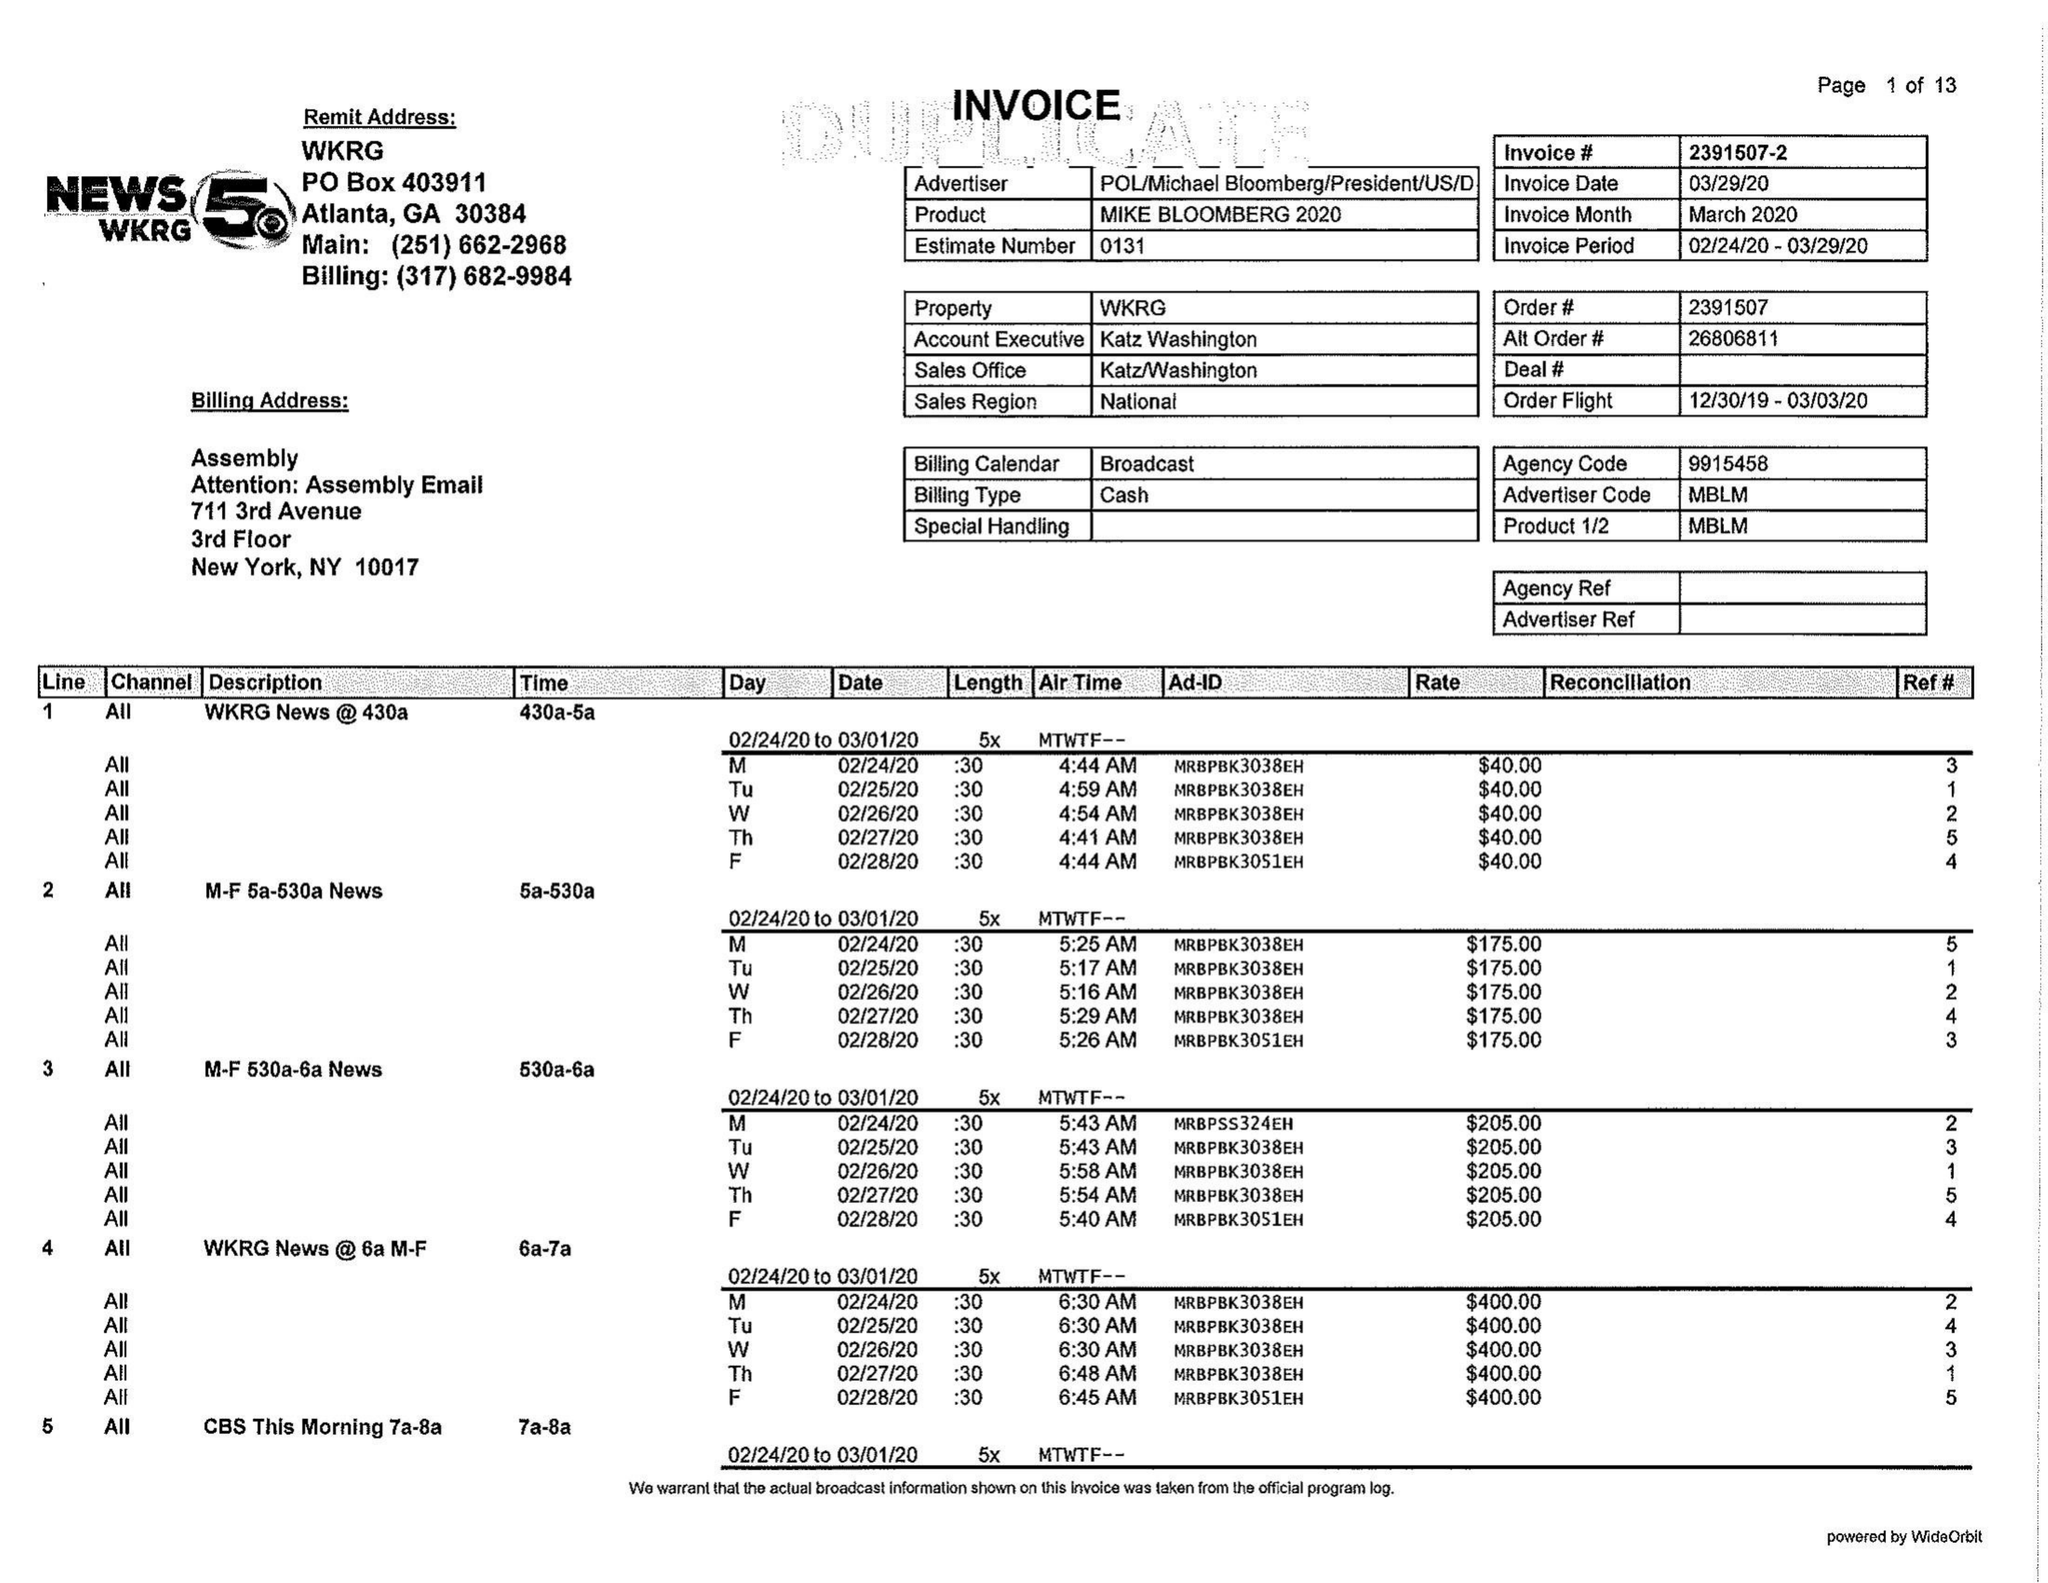What is the value for the flight_from?
Answer the question using a single word or phrase. 12/30/19 